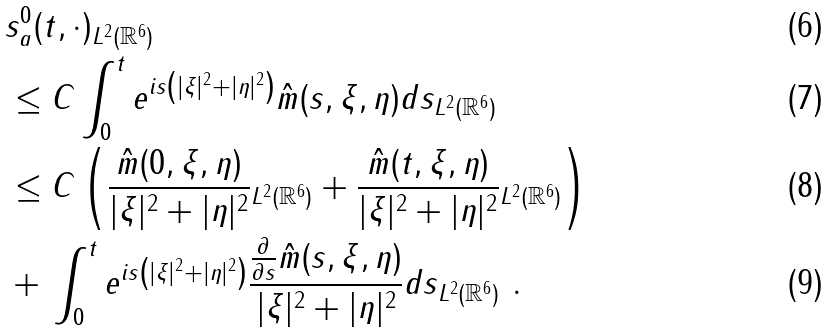Convert formula to latex. <formula><loc_0><loc_0><loc_500><loc_500>& \| s ^ { 0 } _ { a } ( t , \cdot ) \| _ { L ^ { 2 } ( \mathbb { R } ^ { 6 } ) } \\ & \leq C \| \int _ { 0 } ^ { t } e ^ { i s \left ( | \xi | ^ { 2 } + | \eta | ^ { 2 } \right ) } \hat { m } ( s , \xi , \eta ) d s \| _ { L ^ { 2 } ( \mathbb { R } ^ { 6 } ) } \\ & \leq C \left ( \| \frac { \hat { m } ( 0 , \xi , \eta ) } { | \xi | ^ { 2 } + | \eta | ^ { 2 } } \| _ { L ^ { 2 } ( \mathbb { R } ^ { 6 } ) } + \| \frac { \hat { m } ( t , \xi , \eta ) } { | \xi | ^ { 2 } + | \eta | ^ { 2 } } \| _ { L ^ { 2 } ( \mathbb { R } ^ { 6 } ) } \right ) \\ & + \| \int _ { 0 } ^ { t } e ^ { i s \left ( | \xi | ^ { 2 } + | \eta | ^ { 2 } \right ) } \frac { \frac { \partial } { \partial s } \hat { m } ( s , \xi , \eta ) } { | \xi | ^ { 2 } + | \eta | ^ { 2 } } d s \| _ { L ^ { 2 } ( \mathbb { R } ^ { 6 } ) } \ .</formula> 